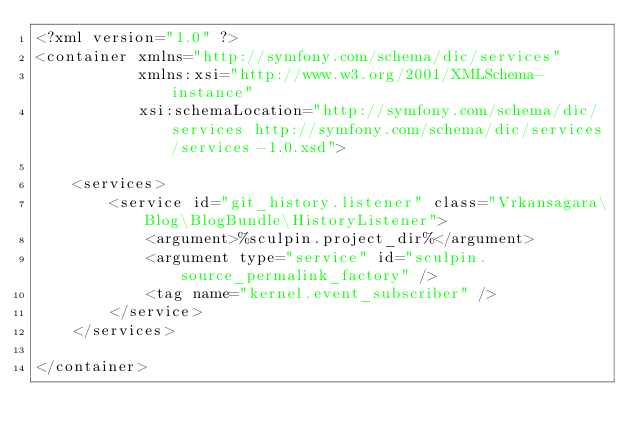Convert code to text. <code><loc_0><loc_0><loc_500><loc_500><_XML_><?xml version="1.0" ?>
<container xmlns="http://symfony.com/schema/dic/services"
           xmlns:xsi="http://www.w3.org/2001/XMLSchema-instance"
           xsi:schemaLocation="http://symfony.com/schema/dic/services http://symfony.com/schema/dic/services/services-1.0.xsd">

    <services>
        <service id="git_history.listener" class="Vrkansagara\Blog\BlogBundle\HistoryListener">
            <argument>%sculpin.project_dir%</argument>
            <argument type="service" id="sculpin.source_permalink_factory" />
            <tag name="kernel.event_subscriber" />
        </service>
    </services>

</container>
</code> 